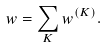Convert formula to latex. <formula><loc_0><loc_0><loc_500><loc_500>w = \sum _ { K } w ^ { ( K ) } .</formula> 